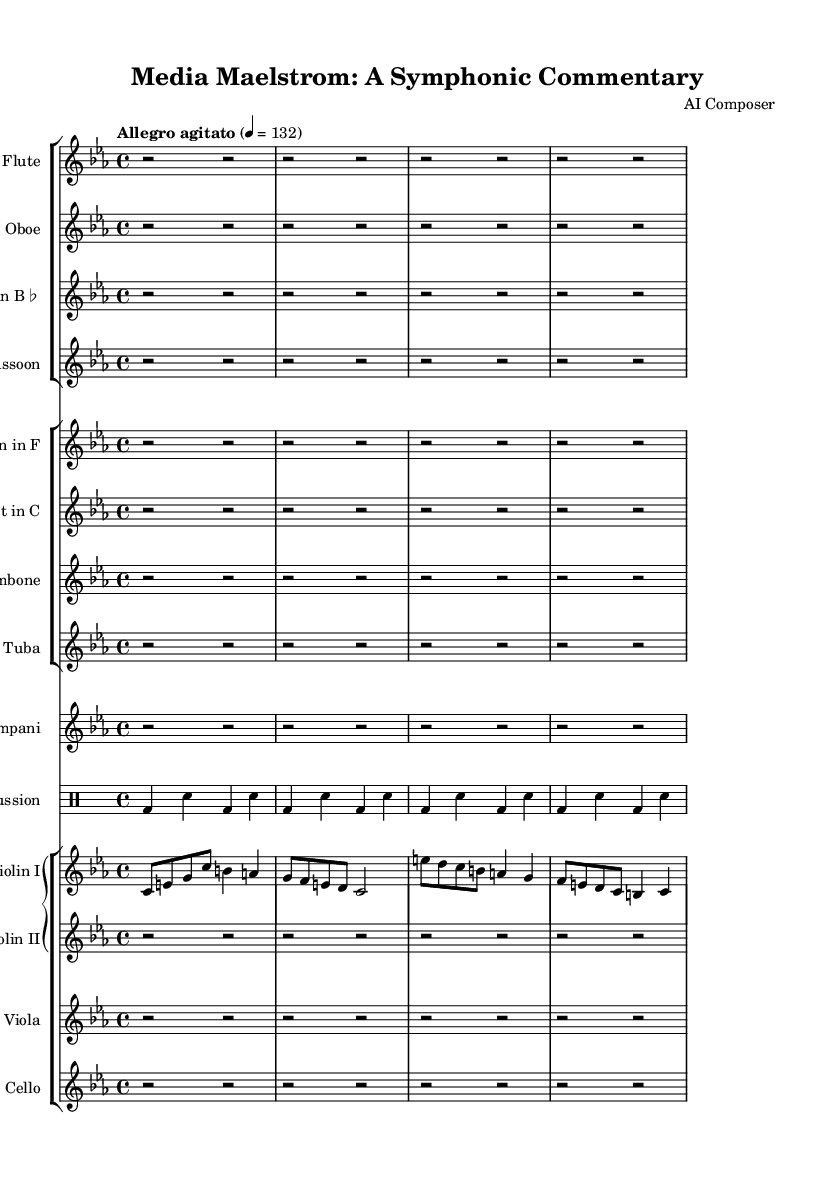what is the key signature of this music? The key signature is C minor, which typically consists of three flats (B♭, E♭, A♭). In the sheet music, no sharps or flats are explicitly shown, indicating it is in C minor.
Answer: C minor what is the time signature of this music? The time signature is indicated at the beginning of the piece, showing a '4/4' signature, meaning there are four beats in a measure and the quarter note gets one beat.
Answer: 4/4 what is the tempo marking of this music? The tempo is specified as "Allegro agitato," which implies a fast (allegro) and agitated character. The beats per minute are written as "4 = 132," indicating a lively pace.
Answer: Allegro agitato how many instruments are included in this score? By counting the different staves in the score section, we can see that there are a total of 15 instruments ranging from woodwinds to strings and percussion.
Answer: 15 which instrument plays the main theme? The main theme is played by the Violin I part, as it contains the melody that is primarily featured in the score.
Answer: Violin I what is the primary mood conveyed in this symphonic work? The combination of the tempo marking, key signature (C minor), and the term "agitato" suggests a mood of tension and urgency, often associated with crises and dramatic narratives.
Answer: Tension in which section is the percussion part written? The percussion part is specifically written in its own DrumStaff section, which is clearly demarcated from other instrumental groups in the score layout.
Answer: DrumStaff 